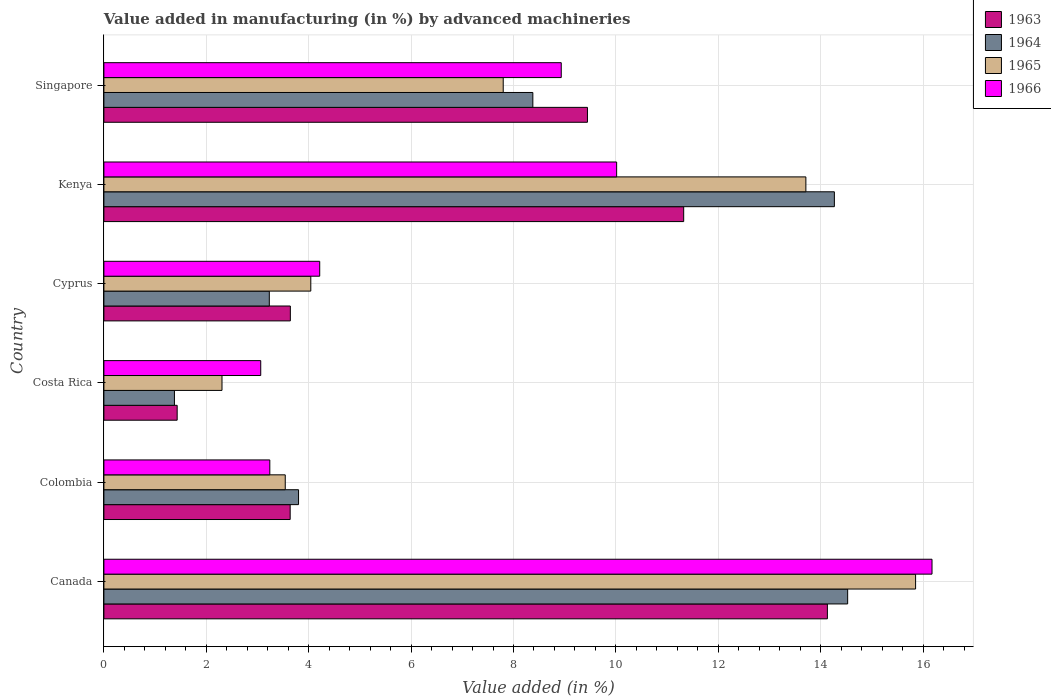How many groups of bars are there?
Keep it short and to the point. 6. What is the label of the 2nd group of bars from the top?
Keep it short and to the point. Kenya. What is the percentage of value added in manufacturing by advanced machineries in 1965 in Cyprus?
Your response must be concise. 4.04. Across all countries, what is the maximum percentage of value added in manufacturing by advanced machineries in 1965?
Your answer should be very brief. 15.85. Across all countries, what is the minimum percentage of value added in manufacturing by advanced machineries in 1966?
Provide a succinct answer. 3.06. In which country was the percentage of value added in manufacturing by advanced machineries in 1964 minimum?
Ensure brevity in your answer.  Costa Rica. What is the total percentage of value added in manufacturing by advanced machineries in 1963 in the graph?
Ensure brevity in your answer.  43.61. What is the difference between the percentage of value added in manufacturing by advanced machineries in 1964 in Canada and that in Singapore?
Provide a succinct answer. 6.15. What is the difference between the percentage of value added in manufacturing by advanced machineries in 1965 in Colombia and the percentage of value added in manufacturing by advanced machineries in 1966 in Singapore?
Give a very brief answer. -5.39. What is the average percentage of value added in manufacturing by advanced machineries in 1965 per country?
Offer a terse response. 7.88. What is the difference between the percentage of value added in manufacturing by advanced machineries in 1966 and percentage of value added in manufacturing by advanced machineries in 1963 in Singapore?
Ensure brevity in your answer.  -0.51. In how many countries, is the percentage of value added in manufacturing by advanced machineries in 1963 greater than 4 %?
Your response must be concise. 3. What is the ratio of the percentage of value added in manufacturing by advanced machineries in 1963 in Kenya to that in Singapore?
Ensure brevity in your answer.  1.2. Is the percentage of value added in manufacturing by advanced machineries in 1963 in Costa Rica less than that in Cyprus?
Ensure brevity in your answer.  Yes. What is the difference between the highest and the second highest percentage of value added in manufacturing by advanced machineries in 1966?
Offer a terse response. 6.16. What is the difference between the highest and the lowest percentage of value added in manufacturing by advanced machineries in 1965?
Offer a terse response. 13.55. In how many countries, is the percentage of value added in manufacturing by advanced machineries in 1964 greater than the average percentage of value added in manufacturing by advanced machineries in 1964 taken over all countries?
Provide a succinct answer. 3. What does the 1st bar from the top in Colombia represents?
Your answer should be compact. 1966. What does the 2nd bar from the bottom in Canada represents?
Ensure brevity in your answer.  1964. How many bars are there?
Keep it short and to the point. 24. Are the values on the major ticks of X-axis written in scientific E-notation?
Give a very brief answer. No. How many legend labels are there?
Give a very brief answer. 4. How are the legend labels stacked?
Ensure brevity in your answer.  Vertical. What is the title of the graph?
Provide a short and direct response. Value added in manufacturing (in %) by advanced machineries. Does "1984" appear as one of the legend labels in the graph?
Provide a succinct answer. No. What is the label or title of the X-axis?
Provide a short and direct response. Value added (in %). What is the label or title of the Y-axis?
Make the answer very short. Country. What is the Value added (in %) in 1963 in Canada?
Give a very brief answer. 14.13. What is the Value added (in %) in 1964 in Canada?
Provide a short and direct response. 14.53. What is the Value added (in %) of 1965 in Canada?
Your answer should be compact. 15.85. What is the Value added (in %) of 1966 in Canada?
Your answer should be compact. 16.17. What is the Value added (in %) of 1963 in Colombia?
Make the answer very short. 3.64. What is the Value added (in %) in 1964 in Colombia?
Offer a very short reply. 3.8. What is the Value added (in %) of 1965 in Colombia?
Keep it short and to the point. 3.54. What is the Value added (in %) of 1966 in Colombia?
Keep it short and to the point. 3.24. What is the Value added (in %) of 1963 in Costa Rica?
Give a very brief answer. 1.43. What is the Value added (in %) in 1964 in Costa Rica?
Offer a terse response. 1.38. What is the Value added (in %) in 1965 in Costa Rica?
Ensure brevity in your answer.  2.31. What is the Value added (in %) in 1966 in Costa Rica?
Provide a succinct answer. 3.06. What is the Value added (in %) in 1963 in Cyprus?
Provide a succinct answer. 3.64. What is the Value added (in %) of 1964 in Cyprus?
Offer a very short reply. 3.23. What is the Value added (in %) of 1965 in Cyprus?
Give a very brief answer. 4.04. What is the Value added (in %) of 1966 in Cyprus?
Provide a short and direct response. 4.22. What is the Value added (in %) in 1963 in Kenya?
Your response must be concise. 11.32. What is the Value added (in %) in 1964 in Kenya?
Ensure brevity in your answer.  14.27. What is the Value added (in %) of 1965 in Kenya?
Provide a succinct answer. 13.71. What is the Value added (in %) of 1966 in Kenya?
Give a very brief answer. 10.01. What is the Value added (in %) of 1963 in Singapore?
Make the answer very short. 9.44. What is the Value added (in %) of 1964 in Singapore?
Offer a terse response. 8.38. What is the Value added (in %) in 1965 in Singapore?
Your answer should be compact. 7.8. What is the Value added (in %) in 1966 in Singapore?
Your answer should be compact. 8.93. Across all countries, what is the maximum Value added (in %) in 1963?
Offer a terse response. 14.13. Across all countries, what is the maximum Value added (in %) in 1964?
Keep it short and to the point. 14.53. Across all countries, what is the maximum Value added (in %) of 1965?
Make the answer very short. 15.85. Across all countries, what is the maximum Value added (in %) in 1966?
Your response must be concise. 16.17. Across all countries, what is the minimum Value added (in %) in 1963?
Your answer should be very brief. 1.43. Across all countries, what is the minimum Value added (in %) of 1964?
Make the answer very short. 1.38. Across all countries, what is the minimum Value added (in %) in 1965?
Give a very brief answer. 2.31. Across all countries, what is the minimum Value added (in %) in 1966?
Your response must be concise. 3.06. What is the total Value added (in %) of 1963 in the graph?
Offer a very short reply. 43.61. What is the total Value added (in %) of 1964 in the graph?
Your response must be concise. 45.58. What is the total Value added (in %) of 1965 in the graph?
Make the answer very short. 47.25. What is the total Value added (in %) of 1966 in the graph?
Your answer should be compact. 45.64. What is the difference between the Value added (in %) of 1963 in Canada and that in Colombia?
Your answer should be very brief. 10.49. What is the difference between the Value added (in %) of 1964 in Canada and that in Colombia?
Give a very brief answer. 10.72. What is the difference between the Value added (in %) of 1965 in Canada and that in Colombia?
Your response must be concise. 12.31. What is the difference between the Value added (in %) in 1966 in Canada and that in Colombia?
Ensure brevity in your answer.  12.93. What is the difference between the Value added (in %) in 1963 in Canada and that in Costa Rica?
Your answer should be very brief. 12.7. What is the difference between the Value added (in %) of 1964 in Canada and that in Costa Rica?
Your answer should be compact. 13.15. What is the difference between the Value added (in %) of 1965 in Canada and that in Costa Rica?
Offer a very short reply. 13.55. What is the difference between the Value added (in %) in 1966 in Canada and that in Costa Rica?
Offer a very short reply. 13.11. What is the difference between the Value added (in %) in 1963 in Canada and that in Cyprus?
Provide a succinct answer. 10.49. What is the difference between the Value added (in %) of 1964 in Canada and that in Cyprus?
Make the answer very short. 11.3. What is the difference between the Value added (in %) of 1965 in Canada and that in Cyprus?
Give a very brief answer. 11.81. What is the difference between the Value added (in %) of 1966 in Canada and that in Cyprus?
Keep it short and to the point. 11.96. What is the difference between the Value added (in %) of 1963 in Canada and that in Kenya?
Your answer should be compact. 2.81. What is the difference between the Value added (in %) in 1964 in Canada and that in Kenya?
Provide a succinct answer. 0.26. What is the difference between the Value added (in %) in 1965 in Canada and that in Kenya?
Give a very brief answer. 2.14. What is the difference between the Value added (in %) of 1966 in Canada and that in Kenya?
Provide a short and direct response. 6.16. What is the difference between the Value added (in %) of 1963 in Canada and that in Singapore?
Your answer should be very brief. 4.69. What is the difference between the Value added (in %) in 1964 in Canada and that in Singapore?
Provide a short and direct response. 6.15. What is the difference between the Value added (in %) of 1965 in Canada and that in Singapore?
Provide a short and direct response. 8.05. What is the difference between the Value added (in %) of 1966 in Canada and that in Singapore?
Your answer should be very brief. 7.24. What is the difference between the Value added (in %) in 1963 in Colombia and that in Costa Rica?
Offer a very short reply. 2.21. What is the difference between the Value added (in %) of 1964 in Colombia and that in Costa Rica?
Make the answer very short. 2.42. What is the difference between the Value added (in %) in 1965 in Colombia and that in Costa Rica?
Your answer should be compact. 1.24. What is the difference between the Value added (in %) in 1966 in Colombia and that in Costa Rica?
Provide a succinct answer. 0.18. What is the difference between the Value added (in %) of 1963 in Colombia and that in Cyprus?
Keep it short and to the point. -0. What is the difference between the Value added (in %) of 1964 in Colombia and that in Cyprus?
Provide a short and direct response. 0.57. What is the difference between the Value added (in %) in 1965 in Colombia and that in Cyprus?
Provide a short and direct response. -0.5. What is the difference between the Value added (in %) in 1966 in Colombia and that in Cyprus?
Ensure brevity in your answer.  -0.97. What is the difference between the Value added (in %) in 1963 in Colombia and that in Kenya?
Your answer should be compact. -7.69. What is the difference between the Value added (in %) of 1964 in Colombia and that in Kenya?
Give a very brief answer. -10.47. What is the difference between the Value added (in %) of 1965 in Colombia and that in Kenya?
Your response must be concise. -10.17. What is the difference between the Value added (in %) in 1966 in Colombia and that in Kenya?
Give a very brief answer. -6.77. What is the difference between the Value added (in %) in 1963 in Colombia and that in Singapore?
Keep it short and to the point. -5.81. What is the difference between the Value added (in %) of 1964 in Colombia and that in Singapore?
Keep it short and to the point. -4.58. What is the difference between the Value added (in %) in 1965 in Colombia and that in Singapore?
Your response must be concise. -4.26. What is the difference between the Value added (in %) of 1966 in Colombia and that in Singapore?
Offer a very short reply. -5.69. What is the difference between the Value added (in %) in 1963 in Costa Rica and that in Cyprus?
Provide a succinct answer. -2.21. What is the difference between the Value added (in %) of 1964 in Costa Rica and that in Cyprus?
Give a very brief answer. -1.85. What is the difference between the Value added (in %) in 1965 in Costa Rica and that in Cyprus?
Ensure brevity in your answer.  -1.73. What is the difference between the Value added (in %) in 1966 in Costa Rica and that in Cyprus?
Offer a terse response. -1.15. What is the difference between the Value added (in %) in 1963 in Costa Rica and that in Kenya?
Give a very brief answer. -9.89. What is the difference between the Value added (in %) in 1964 in Costa Rica and that in Kenya?
Offer a very short reply. -12.89. What is the difference between the Value added (in %) in 1965 in Costa Rica and that in Kenya?
Make the answer very short. -11.4. What is the difference between the Value added (in %) of 1966 in Costa Rica and that in Kenya?
Your response must be concise. -6.95. What is the difference between the Value added (in %) in 1963 in Costa Rica and that in Singapore?
Keep it short and to the point. -8.01. What is the difference between the Value added (in %) in 1964 in Costa Rica and that in Singapore?
Provide a short and direct response. -7. What is the difference between the Value added (in %) of 1965 in Costa Rica and that in Singapore?
Provide a succinct answer. -5.49. What is the difference between the Value added (in %) in 1966 in Costa Rica and that in Singapore?
Ensure brevity in your answer.  -5.87. What is the difference between the Value added (in %) in 1963 in Cyprus and that in Kenya?
Offer a very short reply. -7.68. What is the difference between the Value added (in %) in 1964 in Cyprus and that in Kenya?
Make the answer very short. -11.04. What is the difference between the Value added (in %) in 1965 in Cyprus and that in Kenya?
Offer a very short reply. -9.67. What is the difference between the Value added (in %) of 1966 in Cyprus and that in Kenya?
Your answer should be compact. -5.8. What is the difference between the Value added (in %) in 1963 in Cyprus and that in Singapore?
Give a very brief answer. -5.8. What is the difference between the Value added (in %) in 1964 in Cyprus and that in Singapore?
Give a very brief answer. -5.15. What is the difference between the Value added (in %) in 1965 in Cyprus and that in Singapore?
Offer a very short reply. -3.76. What is the difference between the Value added (in %) in 1966 in Cyprus and that in Singapore?
Offer a very short reply. -4.72. What is the difference between the Value added (in %) of 1963 in Kenya and that in Singapore?
Provide a succinct answer. 1.88. What is the difference between the Value added (in %) of 1964 in Kenya and that in Singapore?
Ensure brevity in your answer.  5.89. What is the difference between the Value added (in %) of 1965 in Kenya and that in Singapore?
Make the answer very short. 5.91. What is the difference between the Value added (in %) in 1966 in Kenya and that in Singapore?
Make the answer very short. 1.08. What is the difference between the Value added (in %) of 1963 in Canada and the Value added (in %) of 1964 in Colombia?
Provide a short and direct response. 10.33. What is the difference between the Value added (in %) in 1963 in Canada and the Value added (in %) in 1965 in Colombia?
Your answer should be compact. 10.59. What is the difference between the Value added (in %) in 1963 in Canada and the Value added (in %) in 1966 in Colombia?
Ensure brevity in your answer.  10.89. What is the difference between the Value added (in %) in 1964 in Canada and the Value added (in %) in 1965 in Colombia?
Provide a short and direct response. 10.98. What is the difference between the Value added (in %) in 1964 in Canada and the Value added (in %) in 1966 in Colombia?
Provide a succinct answer. 11.29. What is the difference between the Value added (in %) of 1965 in Canada and the Value added (in %) of 1966 in Colombia?
Your answer should be compact. 12.61. What is the difference between the Value added (in %) of 1963 in Canada and the Value added (in %) of 1964 in Costa Rica?
Your answer should be very brief. 12.75. What is the difference between the Value added (in %) in 1963 in Canada and the Value added (in %) in 1965 in Costa Rica?
Your response must be concise. 11.82. What is the difference between the Value added (in %) of 1963 in Canada and the Value added (in %) of 1966 in Costa Rica?
Offer a very short reply. 11.07. What is the difference between the Value added (in %) in 1964 in Canada and the Value added (in %) in 1965 in Costa Rica?
Ensure brevity in your answer.  12.22. What is the difference between the Value added (in %) of 1964 in Canada and the Value added (in %) of 1966 in Costa Rica?
Make the answer very short. 11.46. What is the difference between the Value added (in %) in 1965 in Canada and the Value added (in %) in 1966 in Costa Rica?
Your answer should be very brief. 12.79. What is the difference between the Value added (in %) in 1963 in Canada and the Value added (in %) in 1964 in Cyprus?
Provide a short and direct response. 10.9. What is the difference between the Value added (in %) of 1963 in Canada and the Value added (in %) of 1965 in Cyprus?
Offer a very short reply. 10.09. What is the difference between the Value added (in %) of 1963 in Canada and the Value added (in %) of 1966 in Cyprus?
Your answer should be very brief. 9.92. What is the difference between the Value added (in %) of 1964 in Canada and the Value added (in %) of 1965 in Cyprus?
Keep it short and to the point. 10.49. What is the difference between the Value added (in %) in 1964 in Canada and the Value added (in %) in 1966 in Cyprus?
Your answer should be compact. 10.31. What is the difference between the Value added (in %) in 1965 in Canada and the Value added (in %) in 1966 in Cyprus?
Offer a very short reply. 11.64. What is the difference between the Value added (in %) in 1963 in Canada and the Value added (in %) in 1964 in Kenya?
Give a very brief answer. -0.14. What is the difference between the Value added (in %) in 1963 in Canada and the Value added (in %) in 1965 in Kenya?
Keep it short and to the point. 0.42. What is the difference between the Value added (in %) in 1963 in Canada and the Value added (in %) in 1966 in Kenya?
Keep it short and to the point. 4.12. What is the difference between the Value added (in %) in 1964 in Canada and the Value added (in %) in 1965 in Kenya?
Your response must be concise. 0.82. What is the difference between the Value added (in %) of 1964 in Canada and the Value added (in %) of 1966 in Kenya?
Your answer should be compact. 4.51. What is the difference between the Value added (in %) in 1965 in Canada and the Value added (in %) in 1966 in Kenya?
Provide a short and direct response. 5.84. What is the difference between the Value added (in %) of 1963 in Canada and the Value added (in %) of 1964 in Singapore?
Ensure brevity in your answer.  5.75. What is the difference between the Value added (in %) of 1963 in Canada and the Value added (in %) of 1965 in Singapore?
Give a very brief answer. 6.33. What is the difference between the Value added (in %) in 1963 in Canada and the Value added (in %) in 1966 in Singapore?
Offer a terse response. 5.2. What is the difference between the Value added (in %) in 1964 in Canada and the Value added (in %) in 1965 in Singapore?
Your answer should be compact. 6.73. What is the difference between the Value added (in %) of 1964 in Canada and the Value added (in %) of 1966 in Singapore?
Your answer should be compact. 5.59. What is the difference between the Value added (in %) of 1965 in Canada and the Value added (in %) of 1966 in Singapore?
Provide a short and direct response. 6.92. What is the difference between the Value added (in %) in 1963 in Colombia and the Value added (in %) in 1964 in Costa Rica?
Give a very brief answer. 2.26. What is the difference between the Value added (in %) in 1963 in Colombia and the Value added (in %) in 1965 in Costa Rica?
Your answer should be compact. 1.33. What is the difference between the Value added (in %) of 1963 in Colombia and the Value added (in %) of 1966 in Costa Rica?
Offer a terse response. 0.57. What is the difference between the Value added (in %) in 1964 in Colombia and the Value added (in %) in 1965 in Costa Rica?
Your answer should be very brief. 1.49. What is the difference between the Value added (in %) in 1964 in Colombia and the Value added (in %) in 1966 in Costa Rica?
Offer a very short reply. 0.74. What is the difference between the Value added (in %) in 1965 in Colombia and the Value added (in %) in 1966 in Costa Rica?
Your answer should be very brief. 0.48. What is the difference between the Value added (in %) of 1963 in Colombia and the Value added (in %) of 1964 in Cyprus?
Give a very brief answer. 0.41. What is the difference between the Value added (in %) in 1963 in Colombia and the Value added (in %) in 1965 in Cyprus?
Offer a terse response. -0.4. What is the difference between the Value added (in %) of 1963 in Colombia and the Value added (in %) of 1966 in Cyprus?
Your answer should be compact. -0.58. What is the difference between the Value added (in %) of 1964 in Colombia and the Value added (in %) of 1965 in Cyprus?
Your response must be concise. -0.24. What is the difference between the Value added (in %) in 1964 in Colombia and the Value added (in %) in 1966 in Cyprus?
Your answer should be compact. -0.41. What is the difference between the Value added (in %) of 1965 in Colombia and the Value added (in %) of 1966 in Cyprus?
Give a very brief answer. -0.67. What is the difference between the Value added (in %) of 1963 in Colombia and the Value added (in %) of 1964 in Kenya?
Provide a succinct answer. -10.63. What is the difference between the Value added (in %) of 1963 in Colombia and the Value added (in %) of 1965 in Kenya?
Your response must be concise. -10.07. What is the difference between the Value added (in %) in 1963 in Colombia and the Value added (in %) in 1966 in Kenya?
Provide a short and direct response. -6.38. What is the difference between the Value added (in %) in 1964 in Colombia and the Value added (in %) in 1965 in Kenya?
Provide a short and direct response. -9.91. What is the difference between the Value added (in %) of 1964 in Colombia and the Value added (in %) of 1966 in Kenya?
Make the answer very short. -6.21. What is the difference between the Value added (in %) of 1965 in Colombia and the Value added (in %) of 1966 in Kenya?
Your response must be concise. -6.47. What is the difference between the Value added (in %) of 1963 in Colombia and the Value added (in %) of 1964 in Singapore?
Offer a terse response. -4.74. What is the difference between the Value added (in %) in 1963 in Colombia and the Value added (in %) in 1965 in Singapore?
Keep it short and to the point. -4.16. What is the difference between the Value added (in %) of 1963 in Colombia and the Value added (in %) of 1966 in Singapore?
Give a very brief answer. -5.29. What is the difference between the Value added (in %) of 1964 in Colombia and the Value added (in %) of 1965 in Singapore?
Make the answer very short. -4. What is the difference between the Value added (in %) in 1964 in Colombia and the Value added (in %) in 1966 in Singapore?
Your answer should be very brief. -5.13. What is the difference between the Value added (in %) in 1965 in Colombia and the Value added (in %) in 1966 in Singapore?
Your answer should be very brief. -5.39. What is the difference between the Value added (in %) of 1963 in Costa Rica and the Value added (in %) of 1964 in Cyprus?
Your answer should be very brief. -1.8. What is the difference between the Value added (in %) in 1963 in Costa Rica and the Value added (in %) in 1965 in Cyprus?
Your response must be concise. -2.61. What is the difference between the Value added (in %) in 1963 in Costa Rica and the Value added (in %) in 1966 in Cyprus?
Make the answer very short. -2.78. What is the difference between the Value added (in %) in 1964 in Costa Rica and the Value added (in %) in 1965 in Cyprus?
Offer a very short reply. -2.66. What is the difference between the Value added (in %) of 1964 in Costa Rica and the Value added (in %) of 1966 in Cyprus?
Provide a short and direct response. -2.84. What is the difference between the Value added (in %) of 1965 in Costa Rica and the Value added (in %) of 1966 in Cyprus?
Keep it short and to the point. -1.91. What is the difference between the Value added (in %) of 1963 in Costa Rica and the Value added (in %) of 1964 in Kenya?
Your response must be concise. -12.84. What is the difference between the Value added (in %) in 1963 in Costa Rica and the Value added (in %) in 1965 in Kenya?
Offer a very short reply. -12.28. What is the difference between the Value added (in %) in 1963 in Costa Rica and the Value added (in %) in 1966 in Kenya?
Keep it short and to the point. -8.58. What is the difference between the Value added (in %) in 1964 in Costa Rica and the Value added (in %) in 1965 in Kenya?
Offer a very short reply. -12.33. What is the difference between the Value added (in %) of 1964 in Costa Rica and the Value added (in %) of 1966 in Kenya?
Provide a short and direct response. -8.64. What is the difference between the Value added (in %) in 1965 in Costa Rica and the Value added (in %) in 1966 in Kenya?
Provide a short and direct response. -7.71. What is the difference between the Value added (in %) of 1963 in Costa Rica and the Value added (in %) of 1964 in Singapore?
Keep it short and to the point. -6.95. What is the difference between the Value added (in %) of 1963 in Costa Rica and the Value added (in %) of 1965 in Singapore?
Provide a succinct answer. -6.37. What is the difference between the Value added (in %) of 1963 in Costa Rica and the Value added (in %) of 1966 in Singapore?
Provide a succinct answer. -7.5. What is the difference between the Value added (in %) of 1964 in Costa Rica and the Value added (in %) of 1965 in Singapore?
Offer a very short reply. -6.42. What is the difference between the Value added (in %) of 1964 in Costa Rica and the Value added (in %) of 1966 in Singapore?
Keep it short and to the point. -7.55. What is the difference between the Value added (in %) of 1965 in Costa Rica and the Value added (in %) of 1966 in Singapore?
Keep it short and to the point. -6.63. What is the difference between the Value added (in %) of 1963 in Cyprus and the Value added (in %) of 1964 in Kenya?
Provide a succinct answer. -10.63. What is the difference between the Value added (in %) in 1963 in Cyprus and the Value added (in %) in 1965 in Kenya?
Offer a very short reply. -10.07. What is the difference between the Value added (in %) of 1963 in Cyprus and the Value added (in %) of 1966 in Kenya?
Provide a short and direct response. -6.37. What is the difference between the Value added (in %) in 1964 in Cyprus and the Value added (in %) in 1965 in Kenya?
Provide a short and direct response. -10.48. What is the difference between the Value added (in %) of 1964 in Cyprus and the Value added (in %) of 1966 in Kenya?
Keep it short and to the point. -6.78. What is the difference between the Value added (in %) of 1965 in Cyprus and the Value added (in %) of 1966 in Kenya?
Provide a short and direct response. -5.97. What is the difference between the Value added (in %) of 1963 in Cyprus and the Value added (in %) of 1964 in Singapore?
Keep it short and to the point. -4.74. What is the difference between the Value added (in %) in 1963 in Cyprus and the Value added (in %) in 1965 in Singapore?
Make the answer very short. -4.16. What is the difference between the Value added (in %) of 1963 in Cyprus and the Value added (in %) of 1966 in Singapore?
Give a very brief answer. -5.29. What is the difference between the Value added (in %) in 1964 in Cyprus and the Value added (in %) in 1965 in Singapore?
Provide a short and direct response. -4.57. What is the difference between the Value added (in %) of 1964 in Cyprus and the Value added (in %) of 1966 in Singapore?
Your answer should be compact. -5.7. What is the difference between the Value added (in %) in 1965 in Cyprus and the Value added (in %) in 1966 in Singapore?
Ensure brevity in your answer.  -4.89. What is the difference between the Value added (in %) of 1963 in Kenya and the Value added (in %) of 1964 in Singapore?
Provide a short and direct response. 2.95. What is the difference between the Value added (in %) in 1963 in Kenya and the Value added (in %) in 1965 in Singapore?
Keep it short and to the point. 3.52. What is the difference between the Value added (in %) in 1963 in Kenya and the Value added (in %) in 1966 in Singapore?
Offer a terse response. 2.39. What is the difference between the Value added (in %) of 1964 in Kenya and the Value added (in %) of 1965 in Singapore?
Your answer should be very brief. 6.47. What is the difference between the Value added (in %) in 1964 in Kenya and the Value added (in %) in 1966 in Singapore?
Make the answer very short. 5.33. What is the difference between the Value added (in %) of 1965 in Kenya and the Value added (in %) of 1966 in Singapore?
Your response must be concise. 4.78. What is the average Value added (in %) of 1963 per country?
Provide a short and direct response. 7.27. What is the average Value added (in %) in 1964 per country?
Keep it short and to the point. 7.6. What is the average Value added (in %) in 1965 per country?
Ensure brevity in your answer.  7.88. What is the average Value added (in %) of 1966 per country?
Your answer should be compact. 7.61. What is the difference between the Value added (in %) in 1963 and Value added (in %) in 1964 in Canada?
Provide a short and direct response. -0.4. What is the difference between the Value added (in %) in 1963 and Value added (in %) in 1965 in Canada?
Keep it short and to the point. -1.72. What is the difference between the Value added (in %) of 1963 and Value added (in %) of 1966 in Canada?
Ensure brevity in your answer.  -2.04. What is the difference between the Value added (in %) in 1964 and Value added (in %) in 1965 in Canada?
Your response must be concise. -1.33. What is the difference between the Value added (in %) in 1964 and Value added (in %) in 1966 in Canada?
Your answer should be compact. -1.65. What is the difference between the Value added (in %) in 1965 and Value added (in %) in 1966 in Canada?
Make the answer very short. -0.32. What is the difference between the Value added (in %) in 1963 and Value added (in %) in 1964 in Colombia?
Provide a short and direct response. -0.16. What is the difference between the Value added (in %) in 1963 and Value added (in %) in 1965 in Colombia?
Give a very brief answer. 0.1. What is the difference between the Value added (in %) of 1963 and Value added (in %) of 1966 in Colombia?
Give a very brief answer. 0.4. What is the difference between the Value added (in %) in 1964 and Value added (in %) in 1965 in Colombia?
Provide a succinct answer. 0.26. What is the difference between the Value added (in %) in 1964 and Value added (in %) in 1966 in Colombia?
Your answer should be compact. 0.56. What is the difference between the Value added (in %) of 1965 and Value added (in %) of 1966 in Colombia?
Ensure brevity in your answer.  0.3. What is the difference between the Value added (in %) of 1963 and Value added (in %) of 1964 in Costa Rica?
Offer a terse response. 0.05. What is the difference between the Value added (in %) of 1963 and Value added (in %) of 1965 in Costa Rica?
Give a very brief answer. -0.88. What is the difference between the Value added (in %) of 1963 and Value added (in %) of 1966 in Costa Rica?
Offer a terse response. -1.63. What is the difference between the Value added (in %) of 1964 and Value added (in %) of 1965 in Costa Rica?
Offer a terse response. -0.93. What is the difference between the Value added (in %) in 1964 and Value added (in %) in 1966 in Costa Rica?
Ensure brevity in your answer.  -1.69. What is the difference between the Value added (in %) in 1965 and Value added (in %) in 1966 in Costa Rica?
Your answer should be very brief. -0.76. What is the difference between the Value added (in %) in 1963 and Value added (in %) in 1964 in Cyprus?
Provide a short and direct response. 0.41. What is the difference between the Value added (in %) of 1963 and Value added (in %) of 1965 in Cyprus?
Provide a succinct answer. -0.4. What is the difference between the Value added (in %) in 1963 and Value added (in %) in 1966 in Cyprus?
Ensure brevity in your answer.  -0.57. What is the difference between the Value added (in %) of 1964 and Value added (in %) of 1965 in Cyprus?
Your answer should be very brief. -0.81. What is the difference between the Value added (in %) in 1964 and Value added (in %) in 1966 in Cyprus?
Give a very brief answer. -0.98. What is the difference between the Value added (in %) of 1965 and Value added (in %) of 1966 in Cyprus?
Make the answer very short. -0.17. What is the difference between the Value added (in %) of 1963 and Value added (in %) of 1964 in Kenya?
Offer a terse response. -2.94. What is the difference between the Value added (in %) in 1963 and Value added (in %) in 1965 in Kenya?
Provide a succinct answer. -2.39. What is the difference between the Value added (in %) in 1963 and Value added (in %) in 1966 in Kenya?
Provide a short and direct response. 1.31. What is the difference between the Value added (in %) in 1964 and Value added (in %) in 1965 in Kenya?
Keep it short and to the point. 0.56. What is the difference between the Value added (in %) in 1964 and Value added (in %) in 1966 in Kenya?
Your answer should be very brief. 4.25. What is the difference between the Value added (in %) in 1965 and Value added (in %) in 1966 in Kenya?
Provide a short and direct response. 3.7. What is the difference between the Value added (in %) in 1963 and Value added (in %) in 1964 in Singapore?
Ensure brevity in your answer.  1.07. What is the difference between the Value added (in %) of 1963 and Value added (in %) of 1965 in Singapore?
Offer a terse response. 1.64. What is the difference between the Value added (in %) of 1963 and Value added (in %) of 1966 in Singapore?
Provide a succinct answer. 0.51. What is the difference between the Value added (in %) in 1964 and Value added (in %) in 1965 in Singapore?
Provide a short and direct response. 0.58. What is the difference between the Value added (in %) in 1964 and Value added (in %) in 1966 in Singapore?
Make the answer very short. -0.55. What is the difference between the Value added (in %) in 1965 and Value added (in %) in 1966 in Singapore?
Ensure brevity in your answer.  -1.13. What is the ratio of the Value added (in %) in 1963 in Canada to that in Colombia?
Provide a succinct answer. 3.88. What is the ratio of the Value added (in %) of 1964 in Canada to that in Colombia?
Provide a succinct answer. 3.82. What is the ratio of the Value added (in %) of 1965 in Canada to that in Colombia?
Your answer should be very brief. 4.48. What is the ratio of the Value added (in %) in 1966 in Canada to that in Colombia?
Offer a very short reply. 4.99. What is the ratio of the Value added (in %) in 1963 in Canada to that in Costa Rica?
Offer a terse response. 9.87. What is the ratio of the Value added (in %) of 1964 in Canada to that in Costa Rica?
Provide a succinct answer. 10.54. What is the ratio of the Value added (in %) in 1965 in Canada to that in Costa Rica?
Offer a terse response. 6.87. What is the ratio of the Value added (in %) of 1966 in Canada to that in Costa Rica?
Offer a terse response. 5.28. What is the ratio of the Value added (in %) of 1963 in Canada to that in Cyprus?
Ensure brevity in your answer.  3.88. What is the ratio of the Value added (in %) of 1964 in Canada to that in Cyprus?
Ensure brevity in your answer.  4.5. What is the ratio of the Value added (in %) of 1965 in Canada to that in Cyprus?
Keep it short and to the point. 3.92. What is the ratio of the Value added (in %) of 1966 in Canada to that in Cyprus?
Offer a terse response. 3.84. What is the ratio of the Value added (in %) in 1963 in Canada to that in Kenya?
Provide a succinct answer. 1.25. What is the ratio of the Value added (in %) of 1964 in Canada to that in Kenya?
Your answer should be very brief. 1.02. What is the ratio of the Value added (in %) of 1965 in Canada to that in Kenya?
Ensure brevity in your answer.  1.16. What is the ratio of the Value added (in %) in 1966 in Canada to that in Kenya?
Your answer should be compact. 1.62. What is the ratio of the Value added (in %) in 1963 in Canada to that in Singapore?
Your response must be concise. 1.5. What is the ratio of the Value added (in %) in 1964 in Canada to that in Singapore?
Make the answer very short. 1.73. What is the ratio of the Value added (in %) of 1965 in Canada to that in Singapore?
Give a very brief answer. 2.03. What is the ratio of the Value added (in %) in 1966 in Canada to that in Singapore?
Offer a very short reply. 1.81. What is the ratio of the Value added (in %) in 1963 in Colombia to that in Costa Rica?
Your answer should be compact. 2.54. What is the ratio of the Value added (in %) of 1964 in Colombia to that in Costa Rica?
Provide a succinct answer. 2.76. What is the ratio of the Value added (in %) of 1965 in Colombia to that in Costa Rica?
Keep it short and to the point. 1.54. What is the ratio of the Value added (in %) in 1966 in Colombia to that in Costa Rica?
Provide a short and direct response. 1.06. What is the ratio of the Value added (in %) in 1963 in Colombia to that in Cyprus?
Keep it short and to the point. 1. What is the ratio of the Value added (in %) of 1964 in Colombia to that in Cyprus?
Offer a terse response. 1.18. What is the ratio of the Value added (in %) of 1965 in Colombia to that in Cyprus?
Make the answer very short. 0.88. What is the ratio of the Value added (in %) in 1966 in Colombia to that in Cyprus?
Make the answer very short. 0.77. What is the ratio of the Value added (in %) in 1963 in Colombia to that in Kenya?
Keep it short and to the point. 0.32. What is the ratio of the Value added (in %) in 1964 in Colombia to that in Kenya?
Offer a terse response. 0.27. What is the ratio of the Value added (in %) in 1965 in Colombia to that in Kenya?
Offer a terse response. 0.26. What is the ratio of the Value added (in %) in 1966 in Colombia to that in Kenya?
Your answer should be compact. 0.32. What is the ratio of the Value added (in %) of 1963 in Colombia to that in Singapore?
Provide a succinct answer. 0.39. What is the ratio of the Value added (in %) of 1964 in Colombia to that in Singapore?
Your answer should be very brief. 0.45. What is the ratio of the Value added (in %) in 1965 in Colombia to that in Singapore?
Your answer should be compact. 0.45. What is the ratio of the Value added (in %) of 1966 in Colombia to that in Singapore?
Your response must be concise. 0.36. What is the ratio of the Value added (in %) of 1963 in Costa Rica to that in Cyprus?
Provide a short and direct response. 0.39. What is the ratio of the Value added (in %) of 1964 in Costa Rica to that in Cyprus?
Provide a succinct answer. 0.43. What is the ratio of the Value added (in %) of 1965 in Costa Rica to that in Cyprus?
Your response must be concise. 0.57. What is the ratio of the Value added (in %) of 1966 in Costa Rica to that in Cyprus?
Provide a short and direct response. 0.73. What is the ratio of the Value added (in %) in 1963 in Costa Rica to that in Kenya?
Your answer should be very brief. 0.13. What is the ratio of the Value added (in %) of 1964 in Costa Rica to that in Kenya?
Offer a very short reply. 0.1. What is the ratio of the Value added (in %) of 1965 in Costa Rica to that in Kenya?
Your response must be concise. 0.17. What is the ratio of the Value added (in %) of 1966 in Costa Rica to that in Kenya?
Your answer should be very brief. 0.31. What is the ratio of the Value added (in %) of 1963 in Costa Rica to that in Singapore?
Make the answer very short. 0.15. What is the ratio of the Value added (in %) in 1964 in Costa Rica to that in Singapore?
Keep it short and to the point. 0.16. What is the ratio of the Value added (in %) in 1965 in Costa Rica to that in Singapore?
Your answer should be compact. 0.3. What is the ratio of the Value added (in %) of 1966 in Costa Rica to that in Singapore?
Make the answer very short. 0.34. What is the ratio of the Value added (in %) of 1963 in Cyprus to that in Kenya?
Offer a very short reply. 0.32. What is the ratio of the Value added (in %) of 1964 in Cyprus to that in Kenya?
Ensure brevity in your answer.  0.23. What is the ratio of the Value added (in %) of 1965 in Cyprus to that in Kenya?
Offer a terse response. 0.29. What is the ratio of the Value added (in %) of 1966 in Cyprus to that in Kenya?
Give a very brief answer. 0.42. What is the ratio of the Value added (in %) in 1963 in Cyprus to that in Singapore?
Provide a succinct answer. 0.39. What is the ratio of the Value added (in %) of 1964 in Cyprus to that in Singapore?
Give a very brief answer. 0.39. What is the ratio of the Value added (in %) of 1965 in Cyprus to that in Singapore?
Provide a succinct answer. 0.52. What is the ratio of the Value added (in %) of 1966 in Cyprus to that in Singapore?
Offer a very short reply. 0.47. What is the ratio of the Value added (in %) in 1963 in Kenya to that in Singapore?
Offer a terse response. 1.2. What is the ratio of the Value added (in %) of 1964 in Kenya to that in Singapore?
Keep it short and to the point. 1.7. What is the ratio of the Value added (in %) in 1965 in Kenya to that in Singapore?
Your answer should be very brief. 1.76. What is the ratio of the Value added (in %) of 1966 in Kenya to that in Singapore?
Provide a short and direct response. 1.12. What is the difference between the highest and the second highest Value added (in %) of 1963?
Offer a terse response. 2.81. What is the difference between the highest and the second highest Value added (in %) in 1964?
Provide a succinct answer. 0.26. What is the difference between the highest and the second highest Value added (in %) of 1965?
Provide a short and direct response. 2.14. What is the difference between the highest and the second highest Value added (in %) of 1966?
Your answer should be compact. 6.16. What is the difference between the highest and the lowest Value added (in %) in 1963?
Provide a short and direct response. 12.7. What is the difference between the highest and the lowest Value added (in %) of 1964?
Your answer should be compact. 13.15. What is the difference between the highest and the lowest Value added (in %) of 1965?
Make the answer very short. 13.55. What is the difference between the highest and the lowest Value added (in %) in 1966?
Your response must be concise. 13.11. 